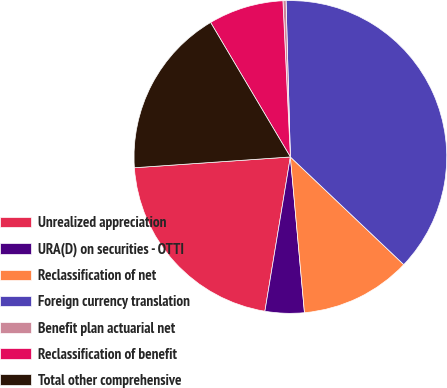Convert chart. <chart><loc_0><loc_0><loc_500><loc_500><pie_chart><fcel>Unrealized appreciation<fcel>URA(D) on securities - OTTI<fcel>Reclassification of net<fcel>Foreign currency translation<fcel>Benefit plan actuarial net<fcel>Reclassification of benefit<fcel>Total other comprehensive<nl><fcel>21.3%<fcel>4.04%<fcel>11.48%<fcel>37.53%<fcel>0.32%<fcel>7.76%<fcel>17.58%<nl></chart> 